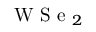Convert formula to latex. <formula><loc_0><loc_0><loc_500><loc_500>W S e _ { 2 }</formula> 